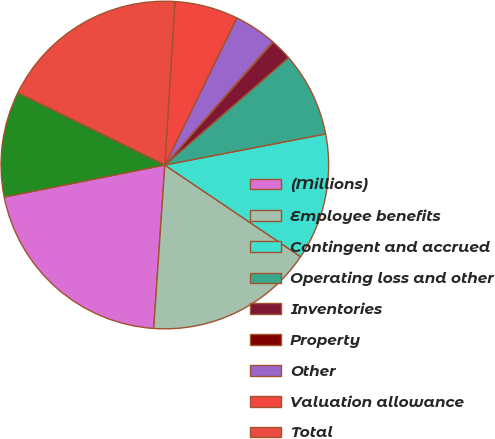Convert chart. <chart><loc_0><loc_0><loc_500><loc_500><pie_chart><fcel>(Millions)<fcel>Employee benefits<fcel>Contingent and accrued<fcel>Operating loss and other<fcel>Inventories<fcel>Property<fcel>Other<fcel>Valuation allowance<fcel>Total<fcel>Intangibles<nl><fcel>20.78%<fcel>16.63%<fcel>12.49%<fcel>8.34%<fcel>2.12%<fcel>0.05%<fcel>4.2%<fcel>6.27%<fcel>18.7%<fcel>10.41%<nl></chart> 